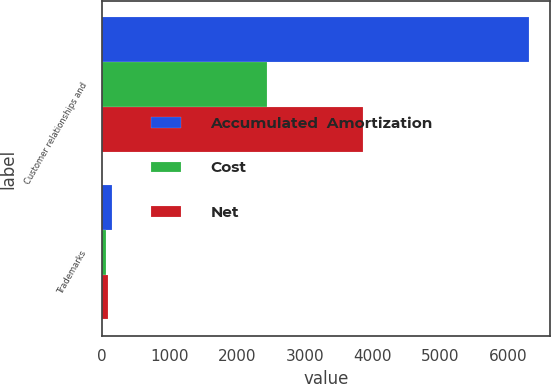<chart> <loc_0><loc_0><loc_500><loc_500><stacked_bar_chart><ecel><fcel>Customer relationships and<fcel>Trademarks<nl><fcel>Accumulated  Amortization<fcel>6300<fcel>149<nl><fcel>Cost<fcel>2442<fcel>57<nl><fcel>Net<fcel>3858<fcel>92<nl></chart> 